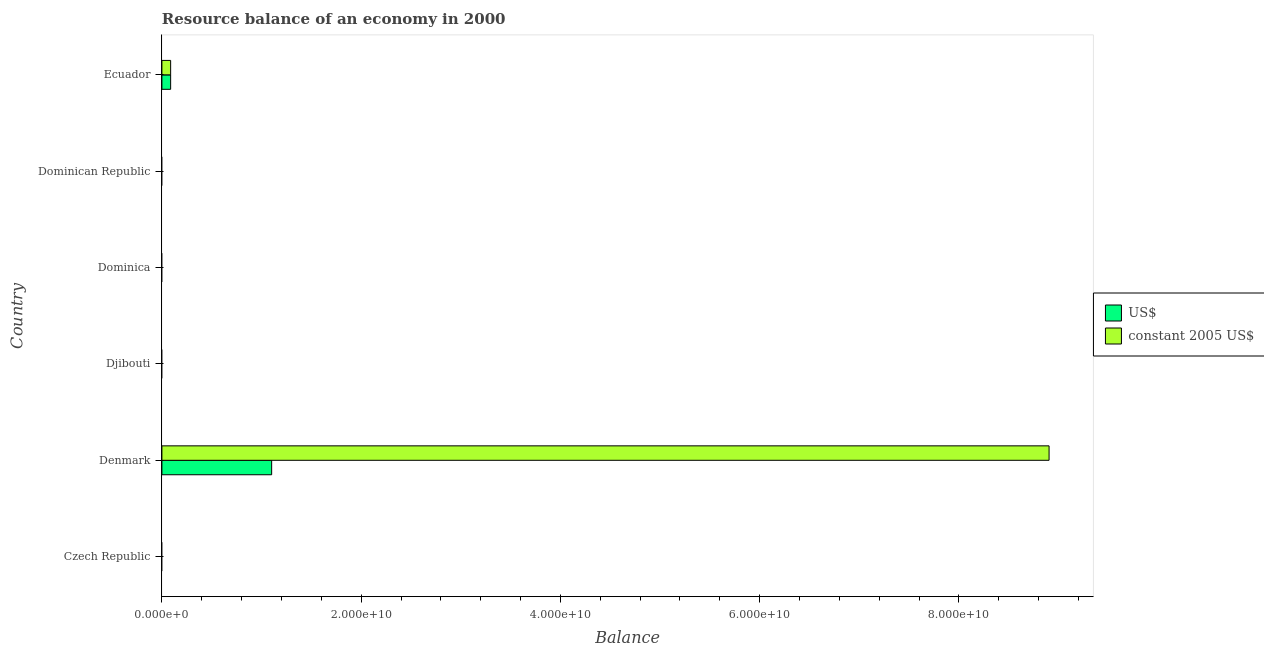How many different coloured bars are there?
Provide a succinct answer. 2. Are the number of bars per tick equal to the number of legend labels?
Offer a very short reply. No. Are the number of bars on each tick of the Y-axis equal?
Offer a very short reply. No. How many bars are there on the 5th tick from the top?
Your response must be concise. 2. What is the label of the 1st group of bars from the top?
Give a very brief answer. Ecuador. What is the resource balance in us$ in Denmark?
Your answer should be compact. 1.10e+1. Across all countries, what is the maximum resource balance in constant us$?
Your answer should be very brief. 8.90e+1. Across all countries, what is the minimum resource balance in us$?
Make the answer very short. 0. In which country was the resource balance in constant us$ maximum?
Keep it short and to the point. Denmark. What is the total resource balance in constant us$ in the graph?
Keep it short and to the point. 8.99e+1. What is the difference between the resource balance in us$ in Ecuador and the resource balance in constant us$ in Czech Republic?
Your answer should be compact. 8.78e+08. What is the average resource balance in us$ per country?
Offer a terse response. 1.98e+09. What is the difference between the resource balance in us$ and resource balance in constant us$ in Denmark?
Ensure brevity in your answer.  -7.80e+1. Is the difference between the resource balance in constant us$ in Denmark and Ecuador greater than the difference between the resource balance in us$ in Denmark and Ecuador?
Offer a very short reply. Yes. What is the difference between the highest and the lowest resource balance in us$?
Keep it short and to the point. 1.10e+1. Are all the bars in the graph horizontal?
Provide a short and direct response. Yes. Does the graph contain any zero values?
Offer a very short reply. Yes. Does the graph contain grids?
Provide a succinct answer. No. Where does the legend appear in the graph?
Provide a short and direct response. Center right. How many legend labels are there?
Make the answer very short. 2. What is the title of the graph?
Your answer should be very brief. Resource balance of an economy in 2000. What is the label or title of the X-axis?
Offer a terse response. Balance. What is the Balance in US$ in Czech Republic?
Your answer should be very brief. 0. What is the Balance of US$ in Denmark?
Offer a terse response. 1.10e+1. What is the Balance of constant 2005 US$ in Denmark?
Provide a succinct answer. 8.90e+1. What is the Balance in US$ in Djibouti?
Make the answer very short. 0. What is the Balance in US$ in Dominica?
Your response must be concise. 0. What is the Balance of US$ in Dominican Republic?
Keep it short and to the point. 0. What is the Balance of US$ in Ecuador?
Ensure brevity in your answer.  8.78e+08. What is the Balance in constant 2005 US$ in Ecuador?
Provide a succinct answer. 8.78e+08. Across all countries, what is the maximum Balance in US$?
Offer a terse response. 1.10e+1. Across all countries, what is the maximum Balance in constant 2005 US$?
Make the answer very short. 8.90e+1. Across all countries, what is the minimum Balance in constant 2005 US$?
Your answer should be compact. 0. What is the total Balance of US$ in the graph?
Keep it short and to the point. 1.19e+1. What is the total Balance of constant 2005 US$ in the graph?
Provide a short and direct response. 8.99e+1. What is the difference between the Balance in US$ in Denmark and that in Ecuador?
Provide a succinct answer. 1.01e+1. What is the difference between the Balance in constant 2005 US$ in Denmark and that in Ecuador?
Provide a short and direct response. 8.82e+1. What is the difference between the Balance of US$ in Denmark and the Balance of constant 2005 US$ in Ecuador?
Your answer should be compact. 1.01e+1. What is the average Balance in US$ per country?
Offer a terse response. 1.98e+09. What is the average Balance in constant 2005 US$ per country?
Provide a short and direct response. 1.50e+1. What is the difference between the Balance of US$ and Balance of constant 2005 US$ in Denmark?
Provide a succinct answer. -7.80e+1. What is the difference between the Balance in US$ and Balance in constant 2005 US$ in Ecuador?
Ensure brevity in your answer.  4.39e+05. What is the ratio of the Balance in US$ in Denmark to that in Ecuador?
Ensure brevity in your answer.  12.55. What is the ratio of the Balance of constant 2005 US$ in Denmark to that in Ecuador?
Offer a terse response. 101.47. What is the difference between the highest and the lowest Balance of US$?
Your answer should be very brief. 1.10e+1. What is the difference between the highest and the lowest Balance in constant 2005 US$?
Your answer should be very brief. 8.90e+1. 